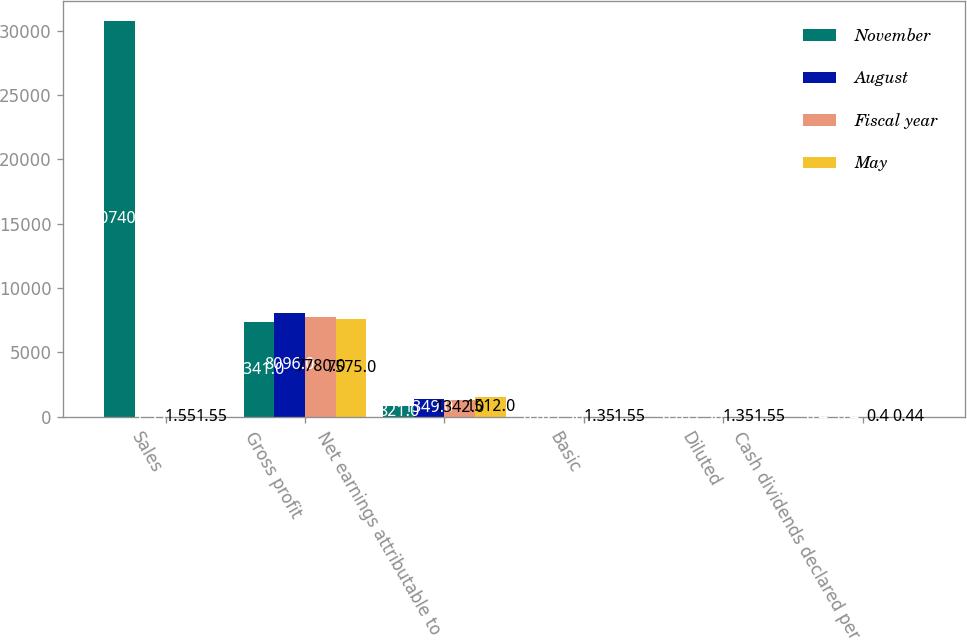Convert chart. <chart><loc_0><loc_0><loc_500><loc_500><stacked_bar_chart><ecel><fcel>Sales<fcel>Gross profit<fcel>Net earnings attributable to<fcel>Basic<fcel>Diluted<fcel>Cash dividends declared per<nl><fcel>November<fcel>30740<fcel>7341<fcel>821<fcel>0.82<fcel>0.81<fcel>0.4<nl><fcel>August<fcel>1.55<fcel>8096<fcel>1349<fcel>1.36<fcel>1.36<fcel>0.4<nl><fcel>Fiscal year<fcel>1.55<fcel>7780<fcel>1342<fcel>1.35<fcel>1.35<fcel>0.4<nl><fcel>May<fcel>1.55<fcel>7575<fcel>1512<fcel>1.55<fcel>1.55<fcel>0.44<nl></chart> 